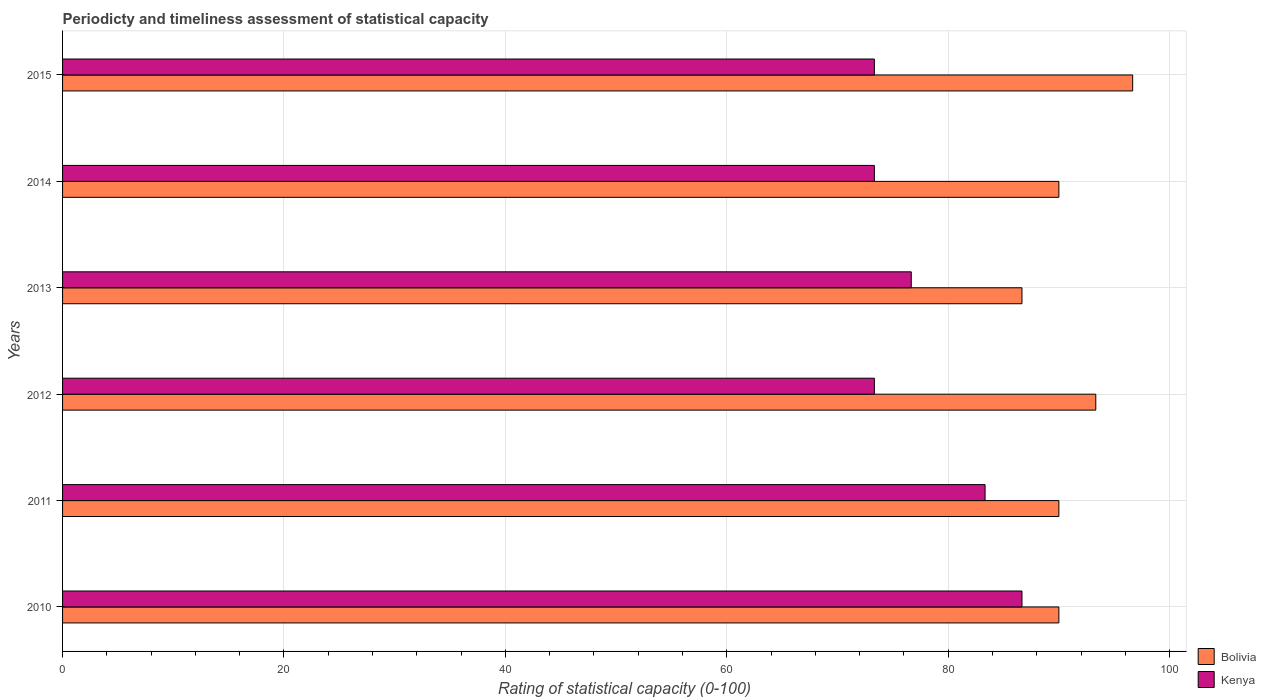How many groups of bars are there?
Provide a short and direct response. 6. Are the number of bars per tick equal to the number of legend labels?
Your answer should be very brief. Yes. How many bars are there on the 3rd tick from the bottom?
Your answer should be very brief. 2. What is the label of the 5th group of bars from the top?
Offer a very short reply. 2011. What is the rating of statistical capacity in Bolivia in 2015?
Provide a short and direct response. 96.67. Across all years, what is the maximum rating of statistical capacity in Bolivia?
Provide a short and direct response. 96.67. Across all years, what is the minimum rating of statistical capacity in Bolivia?
Provide a succinct answer. 86.67. What is the total rating of statistical capacity in Kenya in the graph?
Keep it short and to the point. 466.67. What is the difference between the rating of statistical capacity in Bolivia in 2014 and that in 2015?
Keep it short and to the point. -6.67. What is the difference between the rating of statistical capacity in Bolivia in 2013 and the rating of statistical capacity in Kenya in 2015?
Provide a short and direct response. 13.33. What is the average rating of statistical capacity in Kenya per year?
Keep it short and to the point. 77.78. In the year 2011, what is the difference between the rating of statistical capacity in Kenya and rating of statistical capacity in Bolivia?
Give a very brief answer. -6.67. In how many years, is the rating of statistical capacity in Kenya greater than 40 ?
Your answer should be very brief. 6. What is the ratio of the rating of statistical capacity in Kenya in 2010 to that in 2014?
Provide a succinct answer. 1.18. Is the rating of statistical capacity in Kenya in 2010 less than that in 2013?
Your answer should be very brief. No. Is the difference between the rating of statistical capacity in Kenya in 2010 and 2012 greater than the difference between the rating of statistical capacity in Bolivia in 2010 and 2012?
Provide a short and direct response. Yes. What is the difference between the highest and the second highest rating of statistical capacity in Kenya?
Provide a succinct answer. 3.33. What is the difference between the highest and the lowest rating of statistical capacity in Bolivia?
Your answer should be very brief. 10. Is the sum of the rating of statistical capacity in Kenya in 2012 and 2014 greater than the maximum rating of statistical capacity in Bolivia across all years?
Your answer should be compact. Yes. What does the 2nd bar from the top in 2015 represents?
Your answer should be compact. Bolivia. What does the 1st bar from the bottom in 2011 represents?
Keep it short and to the point. Bolivia. How many bars are there?
Keep it short and to the point. 12. Are all the bars in the graph horizontal?
Make the answer very short. Yes. How many years are there in the graph?
Make the answer very short. 6. Are the values on the major ticks of X-axis written in scientific E-notation?
Offer a terse response. No. Does the graph contain any zero values?
Make the answer very short. No. Where does the legend appear in the graph?
Ensure brevity in your answer.  Bottom right. How many legend labels are there?
Give a very brief answer. 2. What is the title of the graph?
Offer a terse response. Periodicty and timeliness assessment of statistical capacity. Does "Vietnam" appear as one of the legend labels in the graph?
Give a very brief answer. No. What is the label or title of the X-axis?
Provide a succinct answer. Rating of statistical capacity (0-100). What is the label or title of the Y-axis?
Your answer should be compact. Years. What is the Rating of statistical capacity (0-100) in Bolivia in 2010?
Give a very brief answer. 90. What is the Rating of statistical capacity (0-100) in Kenya in 2010?
Offer a terse response. 86.67. What is the Rating of statistical capacity (0-100) in Kenya in 2011?
Offer a very short reply. 83.33. What is the Rating of statistical capacity (0-100) of Bolivia in 2012?
Make the answer very short. 93.33. What is the Rating of statistical capacity (0-100) of Kenya in 2012?
Your answer should be very brief. 73.33. What is the Rating of statistical capacity (0-100) in Bolivia in 2013?
Give a very brief answer. 86.67. What is the Rating of statistical capacity (0-100) in Kenya in 2013?
Your answer should be very brief. 76.67. What is the Rating of statistical capacity (0-100) in Kenya in 2014?
Your response must be concise. 73.33. What is the Rating of statistical capacity (0-100) in Bolivia in 2015?
Ensure brevity in your answer.  96.67. What is the Rating of statistical capacity (0-100) of Kenya in 2015?
Give a very brief answer. 73.33. Across all years, what is the maximum Rating of statistical capacity (0-100) of Bolivia?
Provide a succinct answer. 96.67. Across all years, what is the maximum Rating of statistical capacity (0-100) of Kenya?
Your answer should be compact. 86.67. Across all years, what is the minimum Rating of statistical capacity (0-100) of Bolivia?
Provide a short and direct response. 86.67. Across all years, what is the minimum Rating of statistical capacity (0-100) in Kenya?
Your answer should be very brief. 73.33. What is the total Rating of statistical capacity (0-100) of Bolivia in the graph?
Ensure brevity in your answer.  546.67. What is the total Rating of statistical capacity (0-100) of Kenya in the graph?
Your answer should be compact. 466.67. What is the difference between the Rating of statistical capacity (0-100) of Kenya in 2010 and that in 2011?
Keep it short and to the point. 3.33. What is the difference between the Rating of statistical capacity (0-100) in Kenya in 2010 and that in 2012?
Offer a terse response. 13.33. What is the difference between the Rating of statistical capacity (0-100) of Kenya in 2010 and that in 2013?
Provide a succinct answer. 10. What is the difference between the Rating of statistical capacity (0-100) in Bolivia in 2010 and that in 2014?
Provide a short and direct response. 0. What is the difference between the Rating of statistical capacity (0-100) in Kenya in 2010 and that in 2014?
Ensure brevity in your answer.  13.33. What is the difference between the Rating of statistical capacity (0-100) of Bolivia in 2010 and that in 2015?
Your answer should be very brief. -6.67. What is the difference between the Rating of statistical capacity (0-100) of Kenya in 2010 and that in 2015?
Keep it short and to the point. 13.33. What is the difference between the Rating of statistical capacity (0-100) of Bolivia in 2011 and that in 2012?
Ensure brevity in your answer.  -3.33. What is the difference between the Rating of statistical capacity (0-100) in Kenya in 2011 and that in 2013?
Offer a terse response. 6.67. What is the difference between the Rating of statistical capacity (0-100) of Bolivia in 2011 and that in 2014?
Give a very brief answer. 0. What is the difference between the Rating of statistical capacity (0-100) of Bolivia in 2011 and that in 2015?
Provide a succinct answer. -6.67. What is the difference between the Rating of statistical capacity (0-100) in Kenya in 2011 and that in 2015?
Your answer should be compact. 10. What is the difference between the Rating of statistical capacity (0-100) of Bolivia in 2012 and that in 2013?
Ensure brevity in your answer.  6.67. What is the difference between the Rating of statistical capacity (0-100) of Bolivia in 2012 and that in 2014?
Offer a terse response. 3.33. What is the difference between the Rating of statistical capacity (0-100) of Bolivia in 2012 and that in 2015?
Keep it short and to the point. -3.33. What is the difference between the Rating of statistical capacity (0-100) in Kenya in 2013 and that in 2014?
Make the answer very short. 3.33. What is the difference between the Rating of statistical capacity (0-100) of Kenya in 2013 and that in 2015?
Give a very brief answer. 3.33. What is the difference between the Rating of statistical capacity (0-100) of Bolivia in 2014 and that in 2015?
Provide a short and direct response. -6.67. What is the difference between the Rating of statistical capacity (0-100) in Kenya in 2014 and that in 2015?
Provide a short and direct response. 0. What is the difference between the Rating of statistical capacity (0-100) in Bolivia in 2010 and the Rating of statistical capacity (0-100) in Kenya in 2011?
Provide a short and direct response. 6.67. What is the difference between the Rating of statistical capacity (0-100) in Bolivia in 2010 and the Rating of statistical capacity (0-100) in Kenya in 2012?
Your response must be concise. 16.67. What is the difference between the Rating of statistical capacity (0-100) of Bolivia in 2010 and the Rating of statistical capacity (0-100) of Kenya in 2013?
Your response must be concise. 13.33. What is the difference between the Rating of statistical capacity (0-100) in Bolivia in 2010 and the Rating of statistical capacity (0-100) in Kenya in 2014?
Your answer should be very brief. 16.67. What is the difference between the Rating of statistical capacity (0-100) in Bolivia in 2010 and the Rating of statistical capacity (0-100) in Kenya in 2015?
Provide a short and direct response. 16.67. What is the difference between the Rating of statistical capacity (0-100) of Bolivia in 2011 and the Rating of statistical capacity (0-100) of Kenya in 2012?
Give a very brief answer. 16.67. What is the difference between the Rating of statistical capacity (0-100) in Bolivia in 2011 and the Rating of statistical capacity (0-100) in Kenya in 2013?
Your response must be concise. 13.33. What is the difference between the Rating of statistical capacity (0-100) of Bolivia in 2011 and the Rating of statistical capacity (0-100) of Kenya in 2014?
Make the answer very short. 16.67. What is the difference between the Rating of statistical capacity (0-100) of Bolivia in 2011 and the Rating of statistical capacity (0-100) of Kenya in 2015?
Offer a terse response. 16.67. What is the difference between the Rating of statistical capacity (0-100) in Bolivia in 2012 and the Rating of statistical capacity (0-100) in Kenya in 2013?
Make the answer very short. 16.67. What is the difference between the Rating of statistical capacity (0-100) of Bolivia in 2012 and the Rating of statistical capacity (0-100) of Kenya in 2014?
Make the answer very short. 20. What is the difference between the Rating of statistical capacity (0-100) of Bolivia in 2012 and the Rating of statistical capacity (0-100) of Kenya in 2015?
Your answer should be compact. 20. What is the difference between the Rating of statistical capacity (0-100) in Bolivia in 2013 and the Rating of statistical capacity (0-100) in Kenya in 2014?
Your answer should be very brief. 13.33. What is the difference between the Rating of statistical capacity (0-100) of Bolivia in 2013 and the Rating of statistical capacity (0-100) of Kenya in 2015?
Make the answer very short. 13.33. What is the difference between the Rating of statistical capacity (0-100) in Bolivia in 2014 and the Rating of statistical capacity (0-100) in Kenya in 2015?
Provide a succinct answer. 16.67. What is the average Rating of statistical capacity (0-100) in Bolivia per year?
Your answer should be compact. 91.11. What is the average Rating of statistical capacity (0-100) in Kenya per year?
Give a very brief answer. 77.78. In the year 2010, what is the difference between the Rating of statistical capacity (0-100) of Bolivia and Rating of statistical capacity (0-100) of Kenya?
Your answer should be compact. 3.33. In the year 2011, what is the difference between the Rating of statistical capacity (0-100) in Bolivia and Rating of statistical capacity (0-100) in Kenya?
Your answer should be very brief. 6.67. In the year 2012, what is the difference between the Rating of statistical capacity (0-100) of Bolivia and Rating of statistical capacity (0-100) of Kenya?
Provide a short and direct response. 20. In the year 2013, what is the difference between the Rating of statistical capacity (0-100) of Bolivia and Rating of statistical capacity (0-100) of Kenya?
Ensure brevity in your answer.  10. In the year 2014, what is the difference between the Rating of statistical capacity (0-100) of Bolivia and Rating of statistical capacity (0-100) of Kenya?
Keep it short and to the point. 16.67. In the year 2015, what is the difference between the Rating of statistical capacity (0-100) in Bolivia and Rating of statistical capacity (0-100) in Kenya?
Your answer should be very brief. 23.33. What is the ratio of the Rating of statistical capacity (0-100) of Kenya in 2010 to that in 2011?
Ensure brevity in your answer.  1.04. What is the ratio of the Rating of statistical capacity (0-100) in Kenya in 2010 to that in 2012?
Provide a succinct answer. 1.18. What is the ratio of the Rating of statistical capacity (0-100) of Kenya in 2010 to that in 2013?
Your answer should be compact. 1.13. What is the ratio of the Rating of statistical capacity (0-100) in Kenya in 2010 to that in 2014?
Keep it short and to the point. 1.18. What is the ratio of the Rating of statistical capacity (0-100) in Kenya in 2010 to that in 2015?
Provide a short and direct response. 1.18. What is the ratio of the Rating of statistical capacity (0-100) of Bolivia in 2011 to that in 2012?
Keep it short and to the point. 0.96. What is the ratio of the Rating of statistical capacity (0-100) of Kenya in 2011 to that in 2012?
Ensure brevity in your answer.  1.14. What is the ratio of the Rating of statistical capacity (0-100) of Bolivia in 2011 to that in 2013?
Keep it short and to the point. 1.04. What is the ratio of the Rating of statistical capacity (0-100) in Kenya in 2011 to that in 2013?
Your answer should be compact. 1.09. What is the ratio of the Rating of statistical capacity (0-100) of Kenya in 2011 to that in 2014?
Offer a terse response. 1.14. What is the ratio of the Rating of statistical capacity (0-100) of Bolivia in 2011 to that in 2015?
Your answer should be compact. 0.93. What is the ratio of the Rating of statistical capacity (0-100) of Kenya in 2011 to that in 2015?
Keep it short and to the point. 1.14. What is the ratio of the Rating of statistical capacity (0-100) of Kenya in 2012 to that in 2013?
Give a very brief answer. 0.96. What is the ratio of the Rating of statistical capacity (0-100) of Bolivia in 2012 to that in 2014?
Give a very brief answer. 1.04. What is the ratio of the Rating of statistical capacity (0-100) in Bolivia in 2012 to that in 2015?
Keep it short and to the point. 0.97. What is the ratio of the Rating of statistical capacity (0-100) in Kenya in 2012 to that in 2015?
Give a very brief answer. 1. What is the ratio of the Rating of statistical capacity (0-100) of Bolivia in 2013 to that in 2014?
Provide a succinct answer. 0.96. What is the ratio of the Rating of statistical capacity (0-100) in Kenya in 2013 to that in 2014?
Offer a terse response. 1.05. What is the ratio of the Rating of statistical capacity (0-100) of Bolivia in 2013 to that in 2015?
Ensure brevity in your answer.  0.9. What is the ratio of the Rating of statistical capacity (0-100) of Kenya in 2013 to that in 2015?
Ensure brevity in your answer.  1.05. What is the difference between the highest and the second highest Rating of statistical capacity (0-100) of Bolivia?
Your answer should be compact. 3.33. What is the difference between the highest and the lowest Rating of statistical capacity (0-100) in Kenya?
Your answer should be compact. 13.33. 